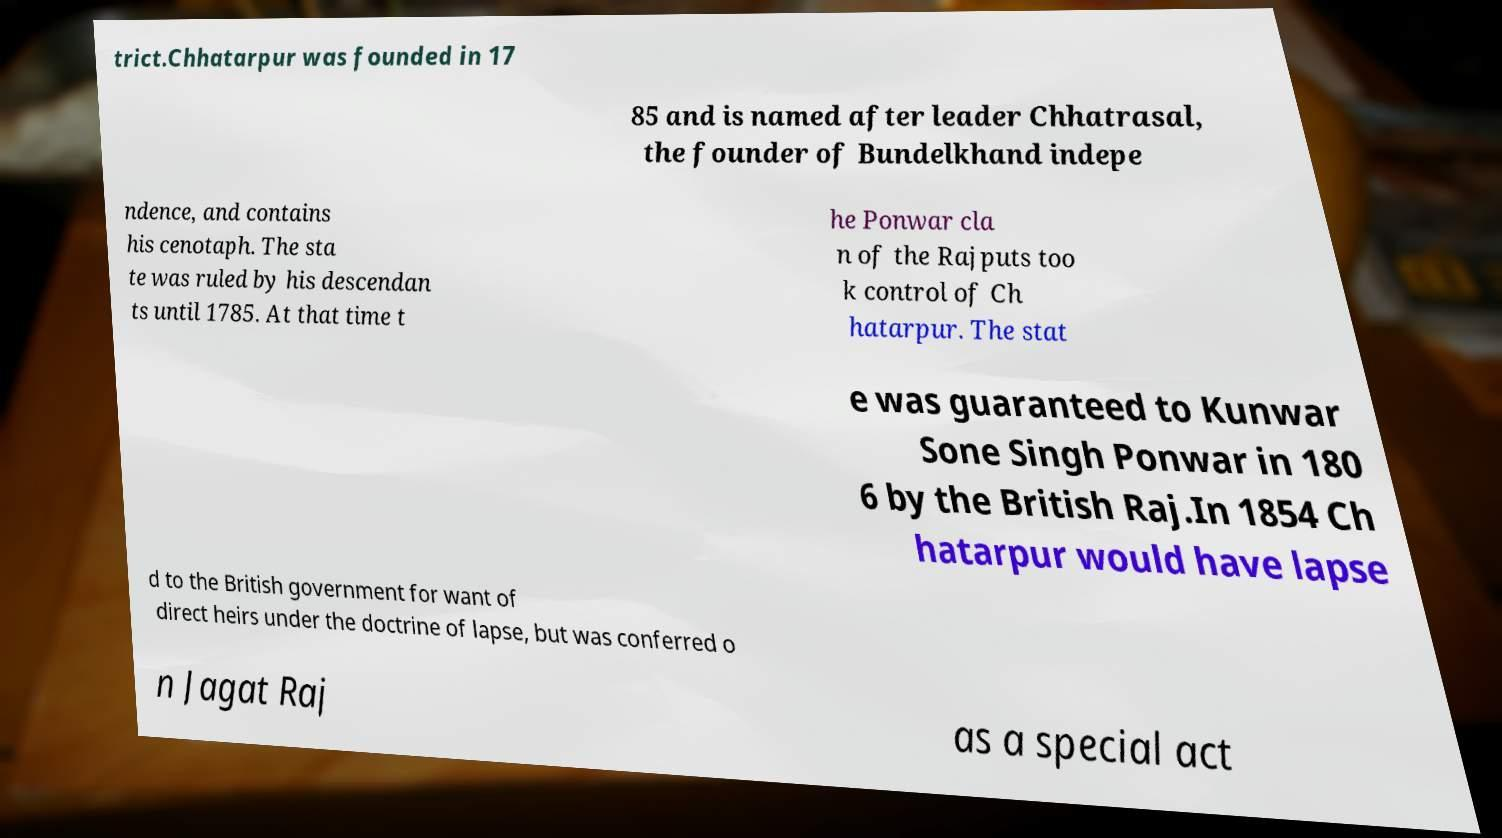For documentation purposes, I need the text within this image transcribed. Could you provide that? trict.Chhatarpur was founded in 17 85 and is named after leader Chhatrasal, the founder of Bundelkhand indepe ndence, and contains his cenotaph. The sta te was ruled by his descendan ts until 1785. At that time t he Ponwar cla n of the Rajputs too k control of Ch hatarpur. The stat e was guaranteed to Kunwar Sone Singh Ponwar in 180 6 by the British Raj.In 1854 Ch hatarpur would have lapse d to the British government for want of direct heirs under the doctrine of lapse, but was conferred o n Jagat Raj as a special act 